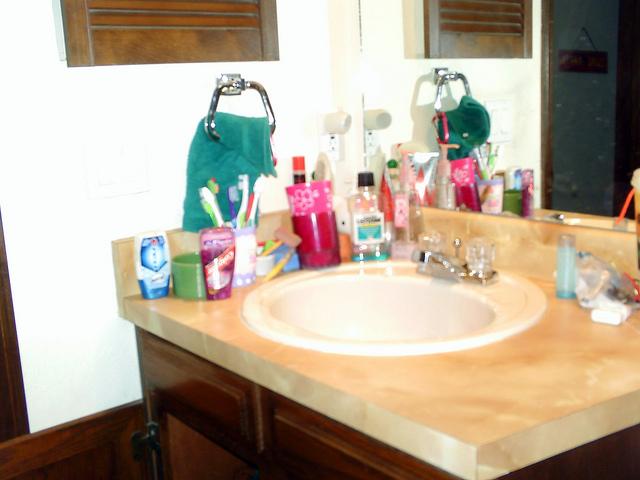Where are the toothbrushes?
Keep it brief. In cup. How much mouthwash is left in the bottle?
Short answer required. Very little. Is this bathroom clean?
Give a very brief answer. Yes. 